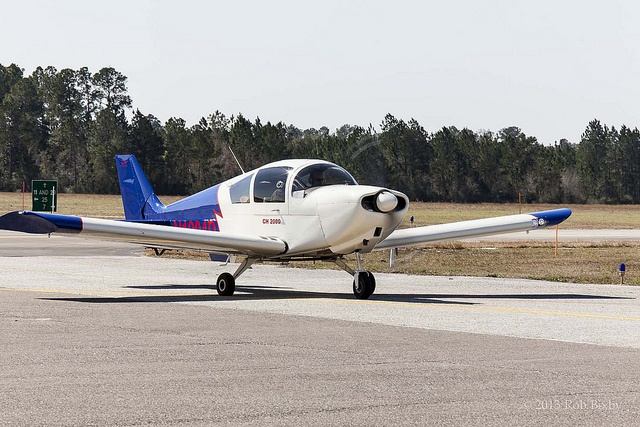Describe the objects in this image and their specific colors. I can see a airplane in white, lightgray, darkgray, black, and gray tones in this image. 